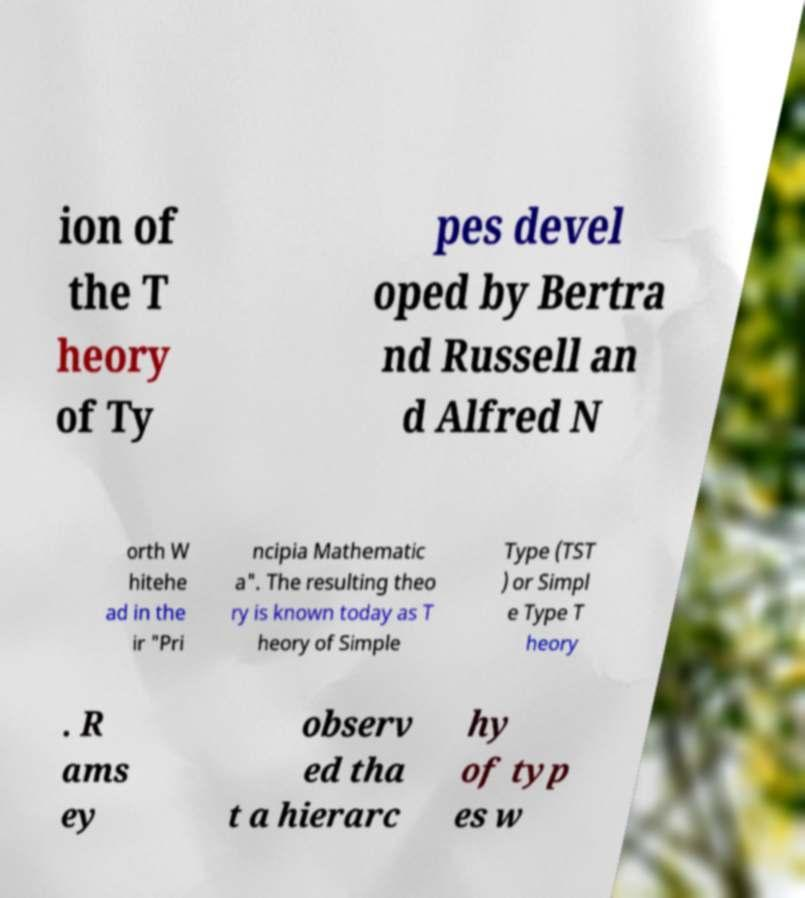What messages or text are displayed in this image? I need them in a readable, typed format. ion of the T heory of Ty pes devel oped by Bertra nd Russell an d Alfred N orth W hitehe ad in the ir "Pri ncipia Mathematic a". The resulting theo ry is known today as T heory of Simple Type (TST ) or Simpl e Type T heory . R ams ey observ ed tha t a hierarc hy of typ es w 